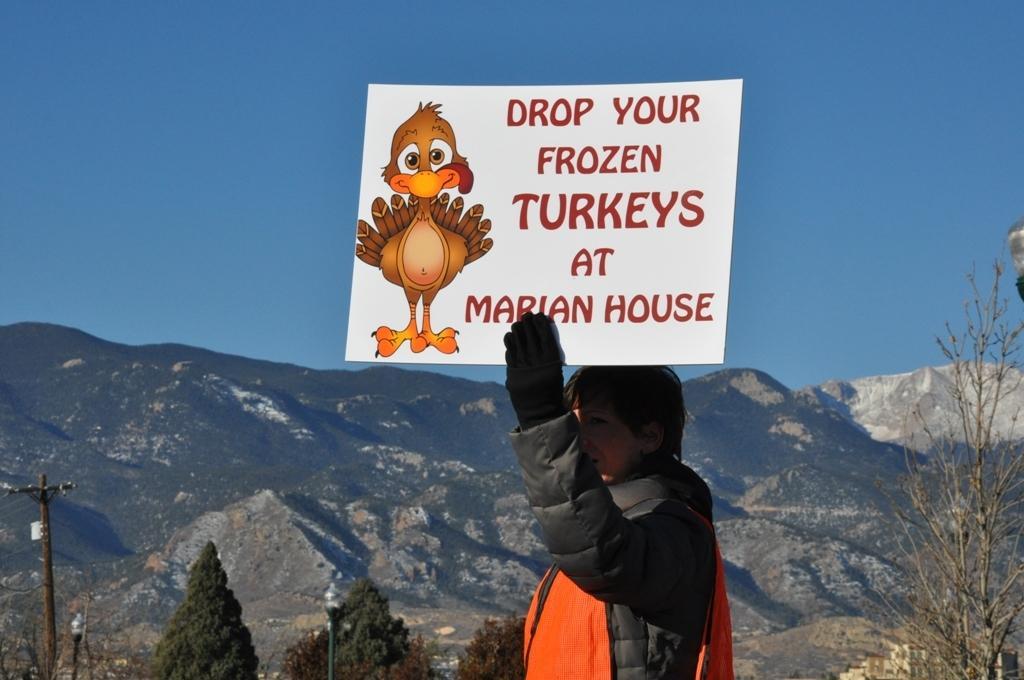Describe this image in one or two sentences. In this image I can see a person wearing black and orange colored jacket is standing and holding a white colored bird in hand. On the board I can see a bird which is brown and orange in color. In the background I can see few trees, a metal pole, few mountains and the sky. 